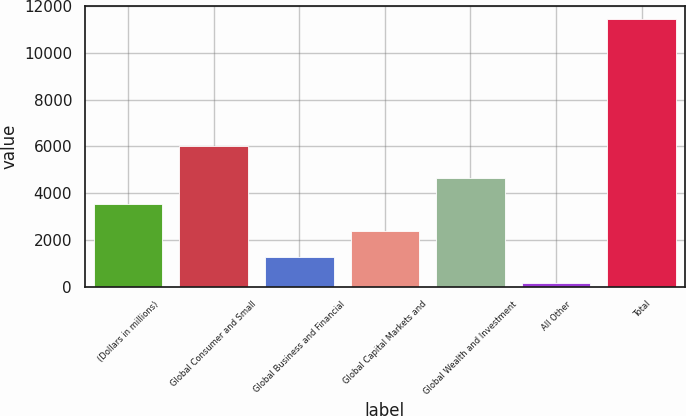<chart> <loc_0><loc_0><loc_500><loc_500><bar_chart><fcel>(Dollars in millions)<fcel>Global Consumer and Small<fcel>Global Business and Financial<fcel>Global Capital Markets and<fcel>Global Wealth and Investment<fcel>All Other<fcel>Total<nl><fcel>3531<fcel>6000<fcel>1267<fcel>2399<fcel>4663<fcel>135<fcel>11455<nl></chart> 